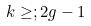<formula> <loc_0><loc_0><loc_500><loc_500>k \geq ; 2 g - 1</formula> 